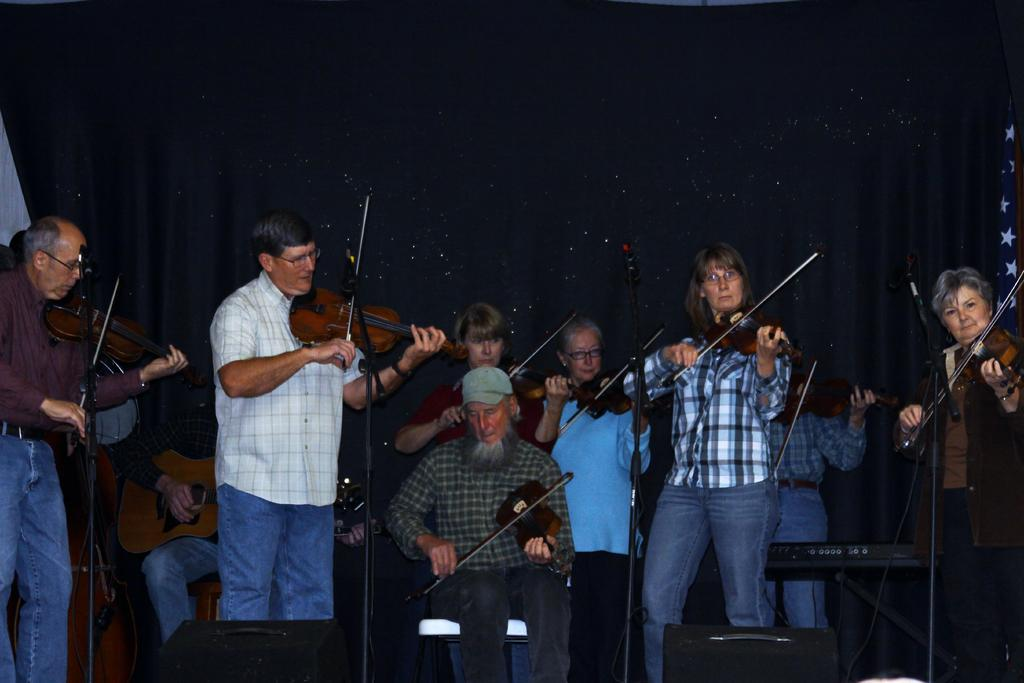What are the people in the image doing? The people in the image are playing violins. What objects are in front of the people? There are microphones in front of the people. How many people are playing violins in the image? The image shows a group of people playing violins, but the exact number cannot be determined without a specific count. What type of needle is being used by the people to play the violins in the image? There are no needles present in the image; the people are playing violins using bows. What type of coach can be seen in the image? There is no coach present in the image. 